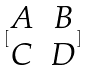Convert formula to latex. <formula><loc_0><loc_0><loc_500><loc_500>[ \begin{matrix} A & B \\ C & D \end{matrix} ]</formula> 